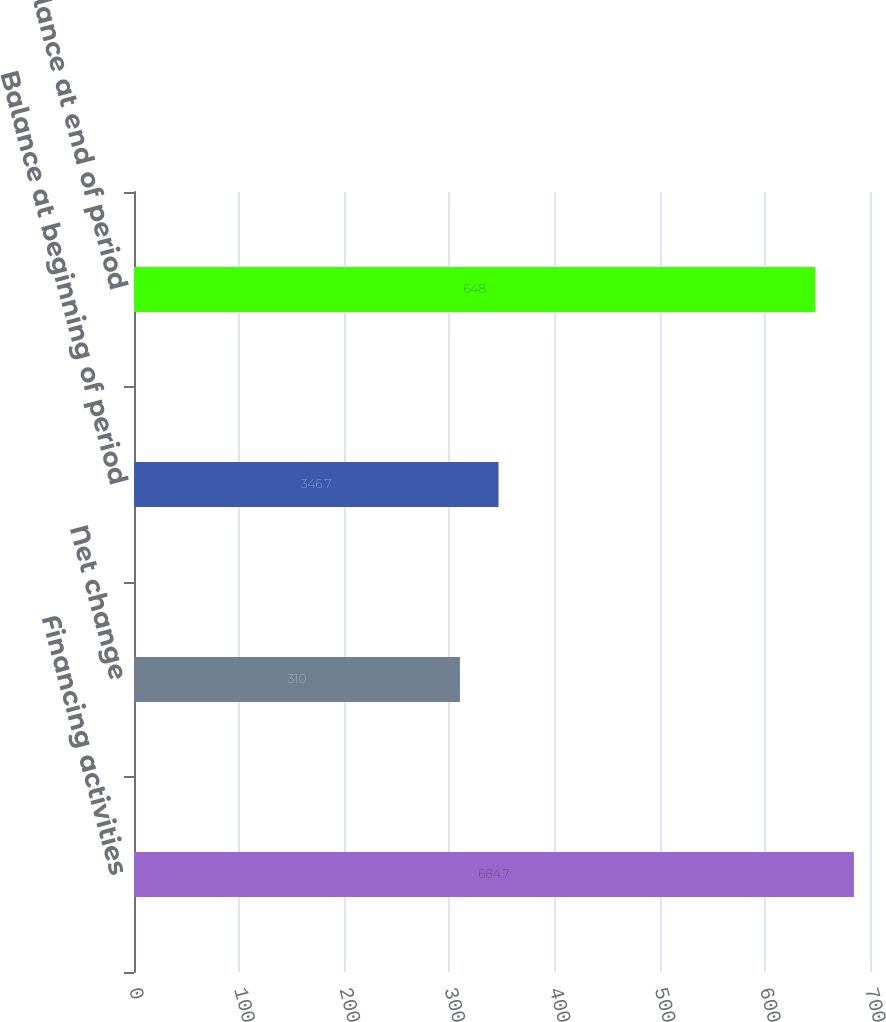Convert chart. <chart><loc_0><loc_0><loc_500><loc_500><bar_chart><fcel>Financing activities<fcel>Net change<fcel>Balance at beginning of period<fcel>Balance at end of period<nl><fcel>684.7<fcel>310<fcel>346.7<fcel>648<nl></chart> 